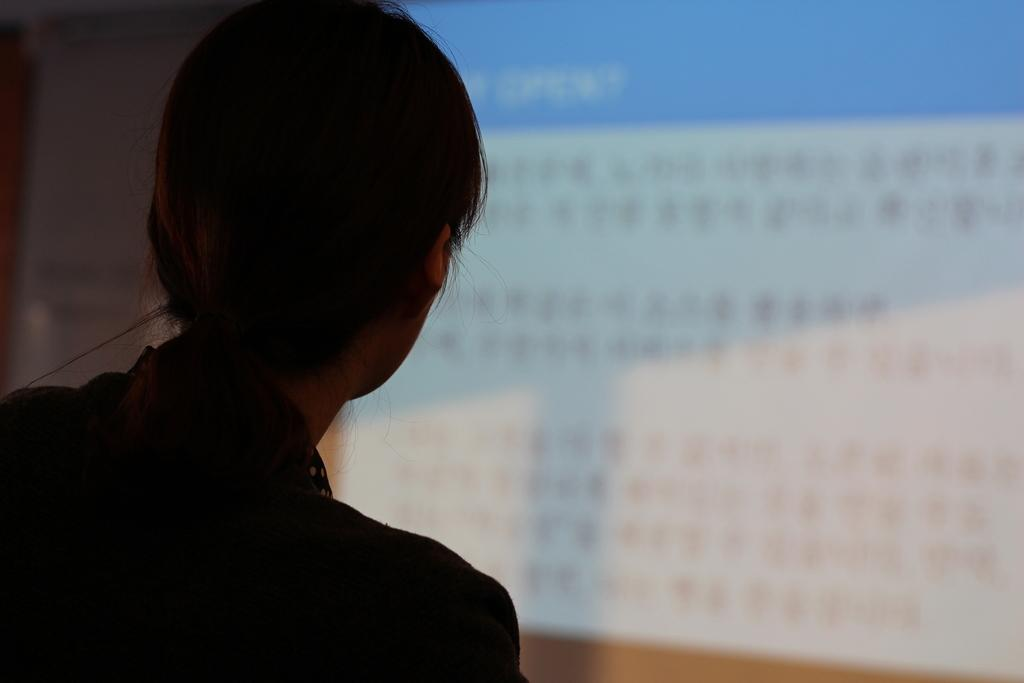What is the main subject in the foreground of the image? There is a woman in the foreground of the image. What is the woman wearing? The woman is wearing a black dress. What can be seen in the background of the image? There is a screen and a wall in the background of the image. Is the woman trying to escape from quicksand in the image? There is no quicksand present in the image, so the woman is not trying to escape from it. 